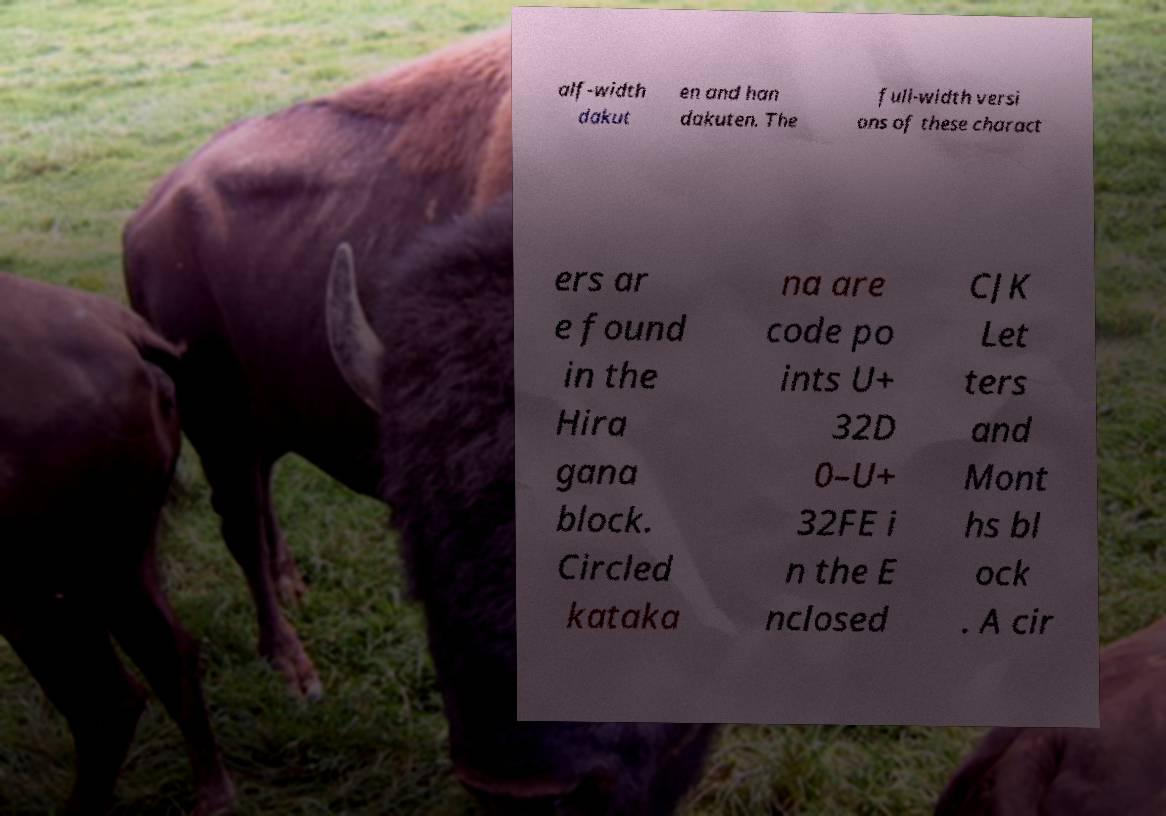Please read and relay the text visible in this image. What does it say? alf-width dakut en and han dakuten. The full-width versi ons of these charact ers ar e found in the Hira gana block. Circled kataka na are code po ints U+ 32D 0–U+ 32FE i n the E nclosed CJK Let ters and Mont hs bl ock . A cir 